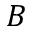Convert formula to latex. <formula><loc_0><loc_0><loc_500><loc_500>B</formula> 